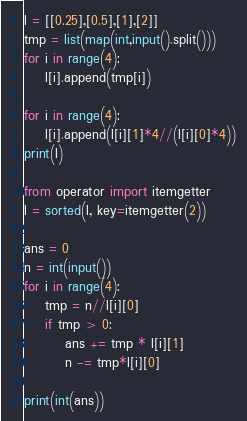<code> <loc_0><loc_0><loc_500><loc_500><_Python_>l = [[0.25],[0.5],[1],[2]]
tmp = list(map(int,input().split()))
for i in range(4):
    l[i].append(tmp[i])

for i in range(4):
    l[i].append(l[i][1]*4//(l[i][0]*4))
print(l)

from operator import itemgetter
l = sorted(l, key=itemgetter(2))

ans = 0
n = int(input())
for i in range(4):
    tmp = n//l[i][0]
    if tmp > 0:
        ans += tmp * l[i][1]
        n -= tmp*l[i][0]

print(int(ans))</code> 